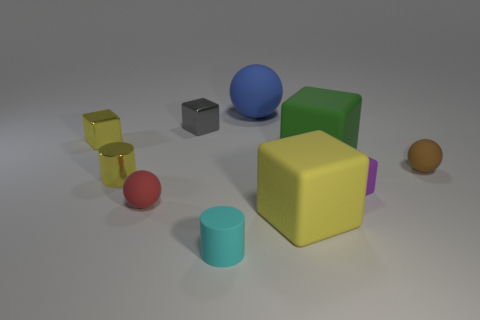Considering the arrangement, does the image imply anything about balance or composition? The arrangement of objects in the image seems deliberate, promoting a balanced and harmonious composition. It doesn't adhere to strict symmetry but instead uses an asymmetrical balance where different objects with varying colors, sizes, and forms are distributed across the scene in a way that is aesthetically pleasing. The visual weight appears evenly spread across the image, creating a stable composition that is easy on the eyes. 